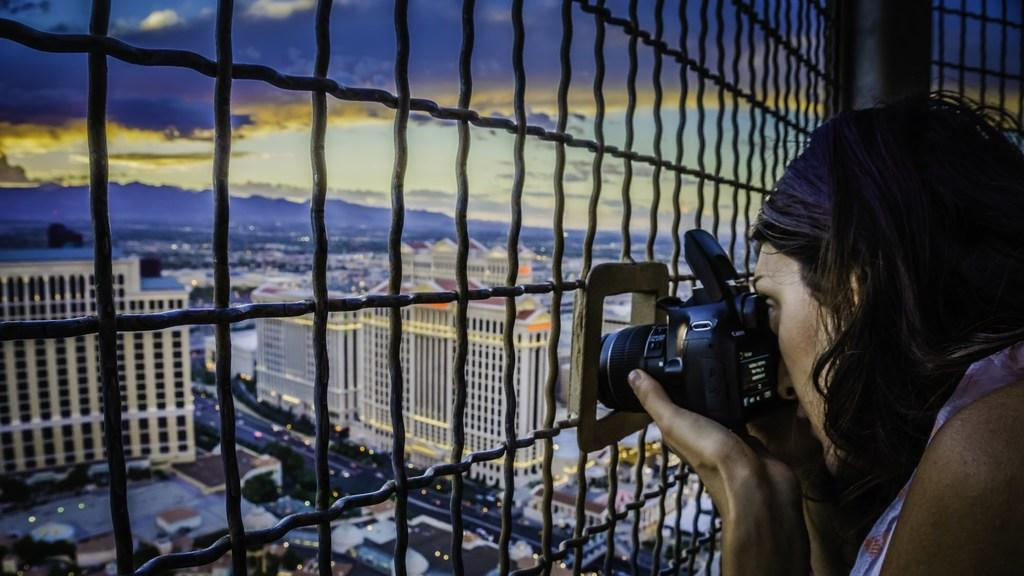Who is the main subject in the image? There is a woman in the image. What is the woman holding in the image? The woman is holding a camera. What type of structures can be seen in the image? There are buildings visible in the image. How would you describe the weather based on the image? The sky is cloudy in the image. What type of pollution can be seen in the image? There is no pollution visible in the image. Can you tell me how many bones are present in the image? There are no bones present in the image. 